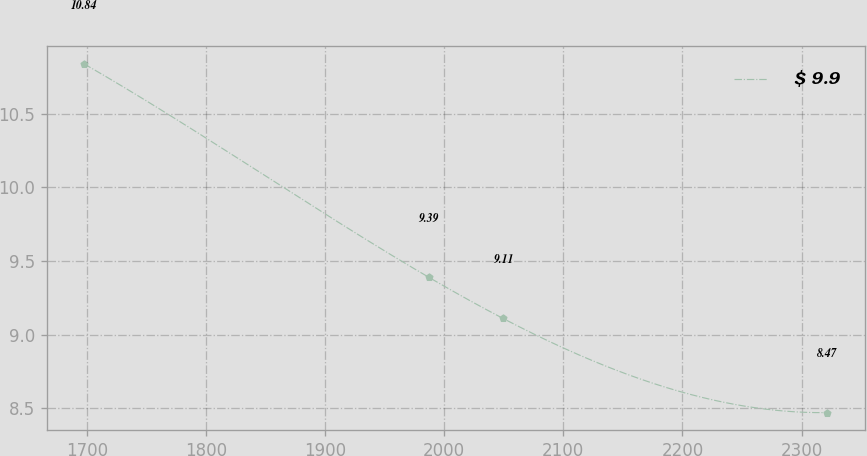Convert chart to OTSL. <chart><loc_0><loc_0><loc_500><loc_500><line_chart><ecel><fcel>$ 9.9<nl><fcel>1697.7<fcel>10.84<nl><fcel>1986.98<fcel>9.39<nl><fcel>2049.37<fcel>9.11<nl><fcel>2321.64<fcel>8.47<nl></chart> 